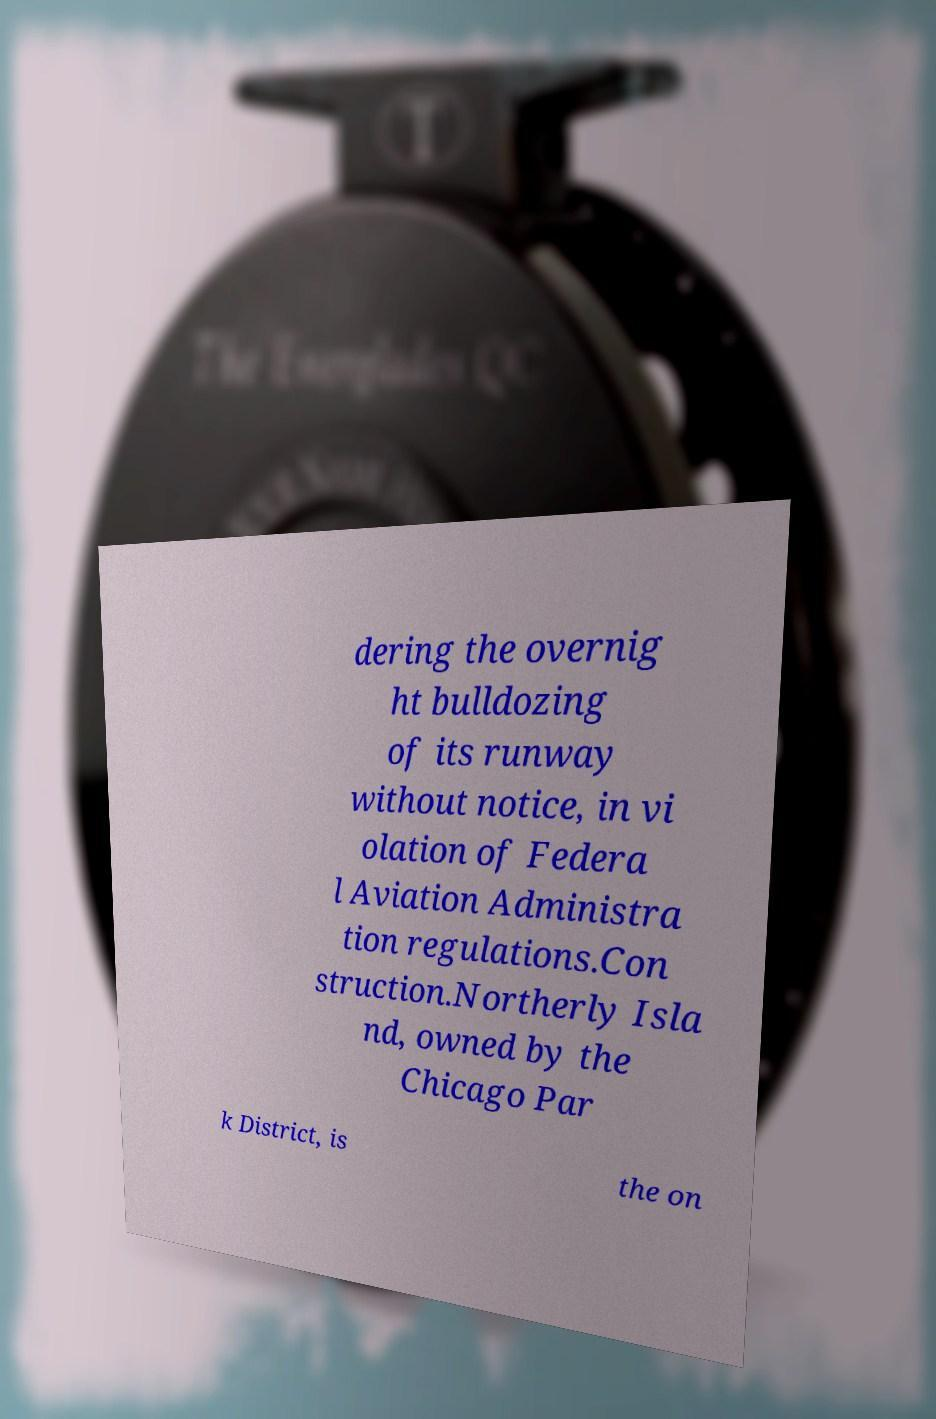Could you extract and type out the text from this image? dering the overnig ht bulldozing of its runway without notice, in vi olation of Federa l Aviation Administra tion regulations.Con struction.Northerly Isla nd, owned by the Chicago Par k District, is the on 